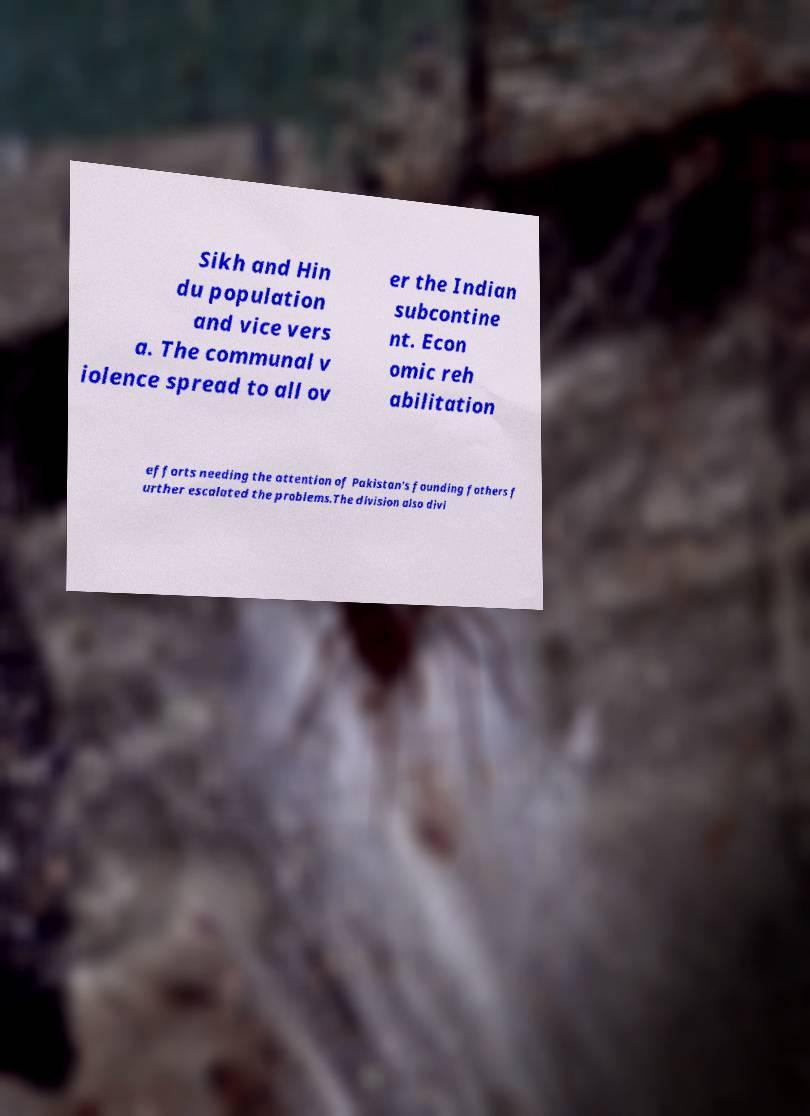Could you extract and type out the text from this image? Sikh and Hin du population and vice vers a. The communal v iolence spread to all ov er the Indian subcontine nt. Econ omic reh abilitation efforts needing the attention of Pakistan's founding fathers f urther escalated the problems.The division also divi 